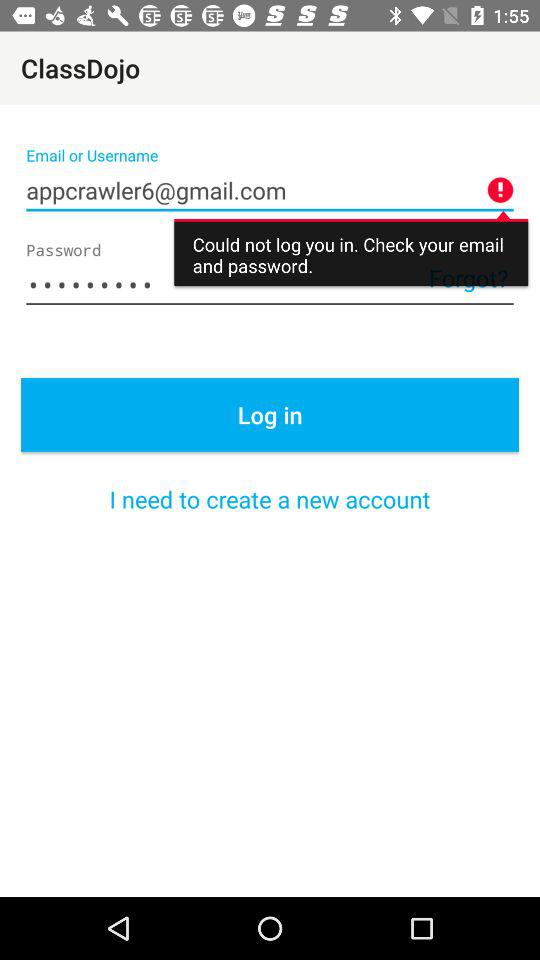How many input fields are in the login screen?
Answer the question using a single word or phrase. 2 